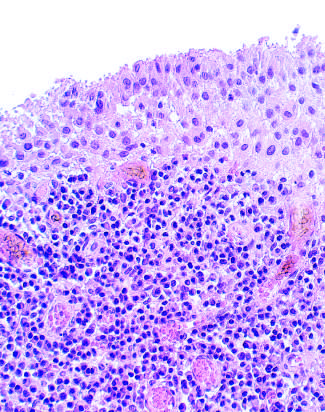what contains a dense lymphoid aggregate?
Answer the question using a single word or phrase. Subsynovial tissue 